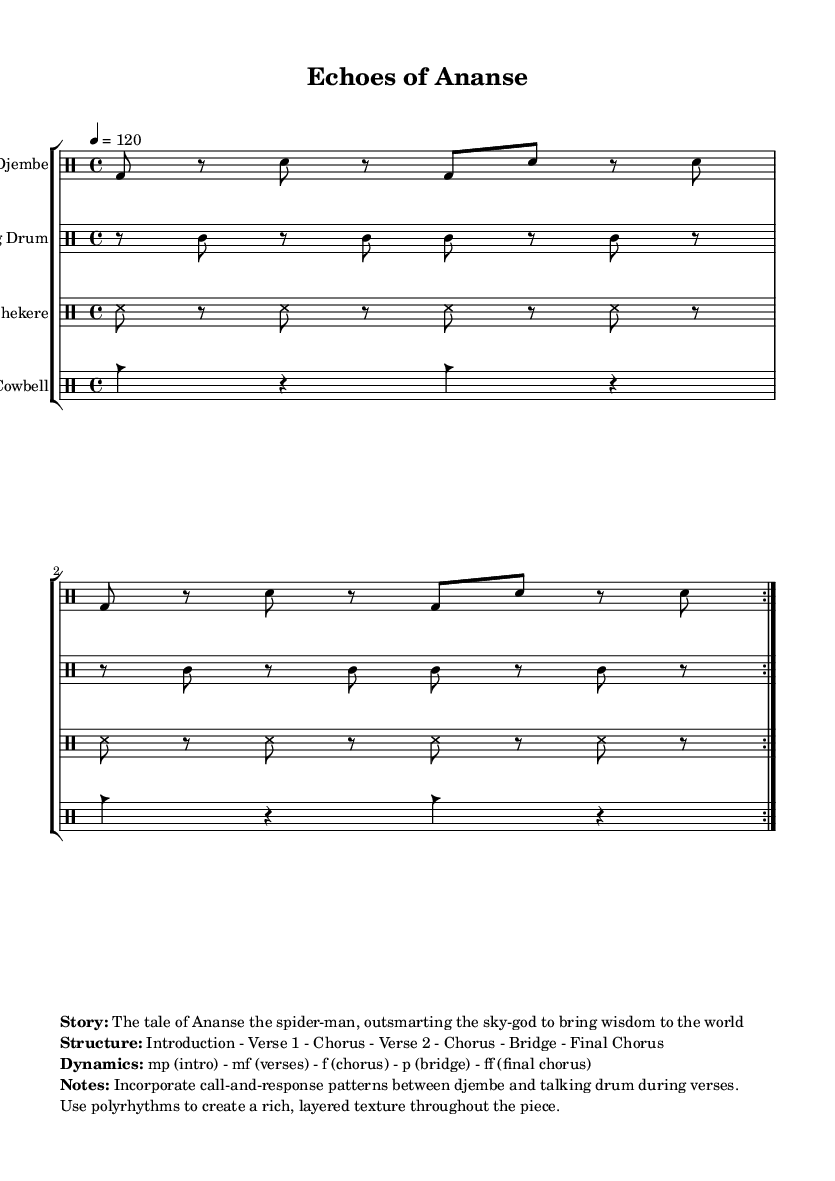What is the key signature of this music? The key signature is G minor, which is indicated by the one flat (B flat) in the key signature box at the beginning of the score.
Answer: G minor What is the time signature of this music? The time signature is 4/4, as shown at the beginning of the score, which indicates that there are four beats in each measure and the quarter note gets one beat.
Answer: 4/4 What is the tempo marking provided in the score? The tempo marking is a quarter note equals 120, which is indicated above the music staff and signifies the speed at which the piece should be played.
Answer: 120 How many times is the djembe rhythm repeated? The djembe rhythm is repeated 2 times, as indicated by the "repeat volta 2" marking in the drummode section for the djembe.
Answer: 2 What is the dynamic level for the bridge section? The dynamic level for the bridge section is piano, as specified in the dynamics section following the story, indicating a quiet passage in the music.
Answer: piano What structure does the piece follow? The structure follows the format: Introduction - Verse 1 - Chorus - Verse 2 - Chorus - Bridge - Final Chorus, as outlined in the score's notes section.
Answer: Introduction - Verse 1 - Chorus - Verse 2 - Chorus - Bridge - Final Chorus What narrative does this music convey? The narrative conveyed in the music is about Ananse the spider-man, who outsmarts the sky-god to bring wisdom to the world, as mentioned in the story section of the markup.
Answer: The tale of Ananse the spider-man 